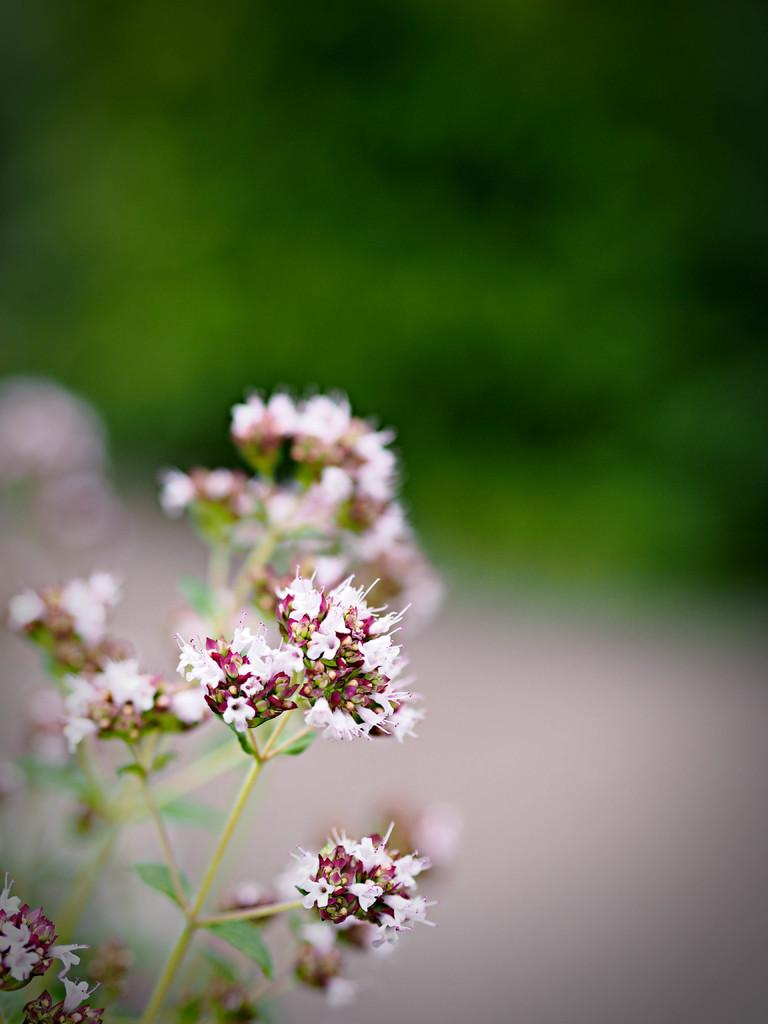What type of living organisms are present in the image? There are plants in the image. What specific features can be observed on the plants? The plants have leaves and flowers. Can you describe the background of the image? The background of the image is blurry. What type of string can be seen tied around the mouth of the ship in the image? There is no ship present in the image, and therefore no string or mouth can be observed. 